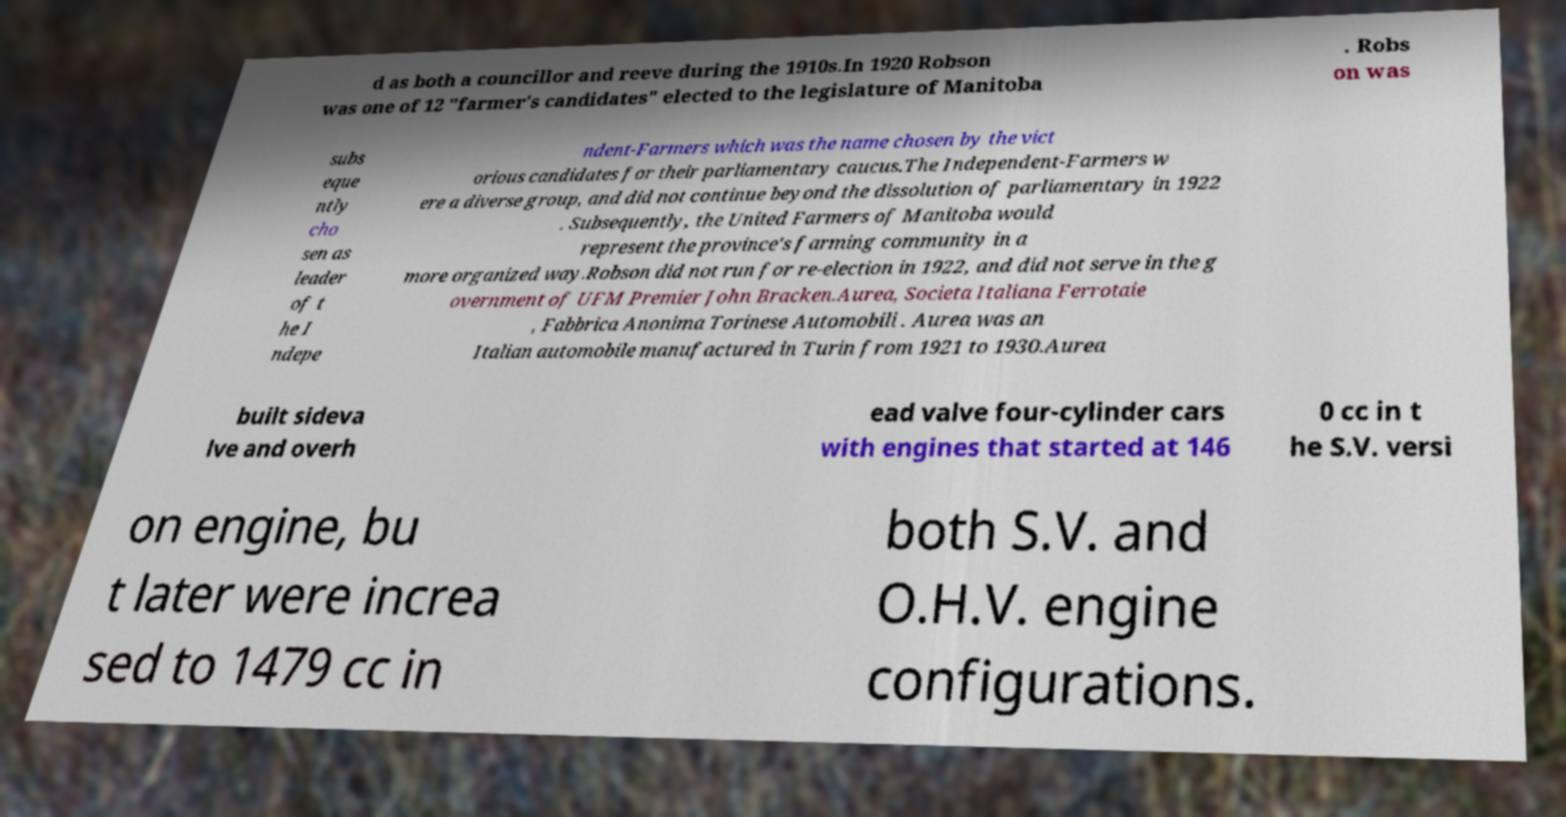Please identify and transcribe the text found in this image. d as both a councillor and reeve during the 1910s.In 1920 Robson was one of 12 "farmer's candidates" elected to the legislature of Manitoba . Robs on was subs eque ntly cho sen as leader of t he I ndepe ndent-Farmers which was the name chosen by the vict orious candidates for their parliamentary caucus.The Independent-Farmers w ere a diverse group, and did not continue beyond the dissolution of parliamentary in 1922 . Subsequently, the United Farmers of Manitoba would represent the province's farming community in a more organized way.Robson did not run for re-election in 1922, and did not serve in the g overnment of UFM Premier John Bracken.Aurea, Societa Italiana Ferrotaie , Fabbrica Anonima Torinese Automobili . Aurea was an Italian automobile manufactured in Turin from 1921 to 1930.Aurea built sideva lve and overh ead valve four-cylinder cars with engines that started at 146 0 cc in t he S.V. versi on engine, bu t later were increa sed to 1479 cc in both S.V. and O.H.V. engine configurations. 